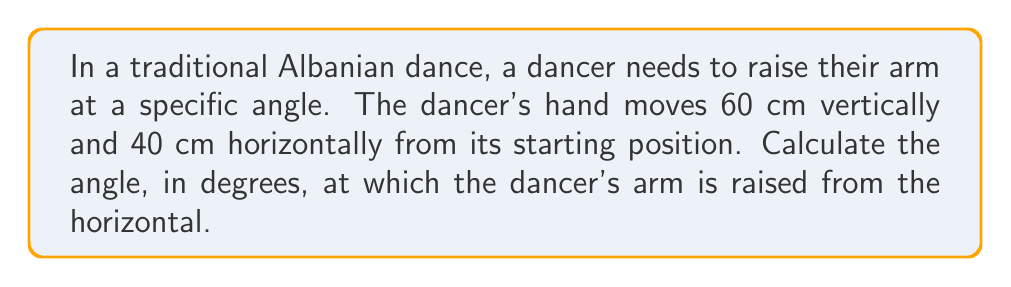Show me your answer to this math problem. To solve this problem, we can use trigonometry, specifically the arctangent function. Let's break it down step-by-step:

1. Visualize the arm movement as forming a right triangle:
   - The vertical movement (60 cm) forms the opposite side
   - The horizontal movement (40 cm) forms the adjacent side
   - The arm forms the hypotenuse

2. We need to find the angle between the horizontal (adjacent side) and the arm (hypotenuse). This angle is given by the arctangent of the opposite side divided by the adjacent side.

3. Let $\theta$ be the angle we're looking for. Then:

   $$\theta = \arctan(\frac{\text{opposite}}{\text{adjacent}})$$

4. Substituting our values:

   $$\theta = \arctan(\frac{60}{40})$$

5. Simplify the fraction:

   $$\theta = \arctan(1.5)$$

6. Use a calculator or mathematical software to evaluate this:

   $$\theta \approx 56.31^\circ$$

7. Round to two decimal places for our final answer.

[asy]
unitsize(1cm);
draw((0,0)--(4,0)--(4,6)--(0,0));
label("40 cm", (2,0), S);
label("60 cm", (4,3), E);
label("$\theta$", (0.5,0.3), NW);
draw((0.5,0)..arc((0,0),0.5,0,56.31));
[/asy]
Answer: $56.31^\circ$ 